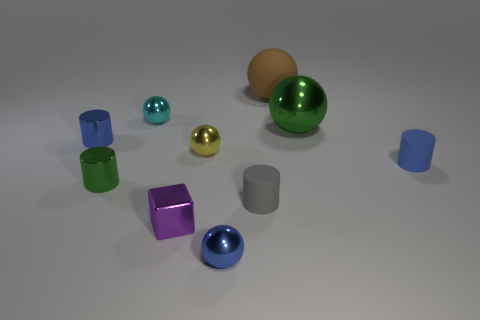What shape is the metallic thing that is both in front of the green sphere and behind the tiny yellow thing? cylinder 